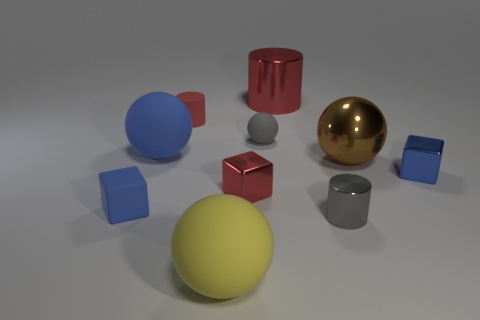Is there another cylinder that has the same material as the large cylinder?
Make the answer very short. Yes. There is a small gray metal object; what shape is it?
Your answer should be very brief. Cylinder. What is the color of the small cylinder that is the same material as the red cube?
Ensure brevity in your answer.  Gray. How many blue things are small objects or metal cubes?
Offer a terse response. 2. Is the number of brown spheres greater than the number of tiny things?
Your answer should be compact. No. How many things are either small rubber cubes in front of the blue matte ball or small things that are behind the big shiny ball?
Offer a very short reply. 3. What is the color of the matte cylinder that is the same size as the gray sphere?
Your response must be concise. Red. Are the large yellow thing and the gray ball made of the same material?
Ensure brevity in your answer.  Yes. What is the tiny blue block right of the big shiny thing on the right side of the gray metal cylinder made of?
Your answer should be compact. Metal. Are there more tiny cubes to the right of the gray metal thing than green matte balls?
Keep it short and to the point. Yes. 